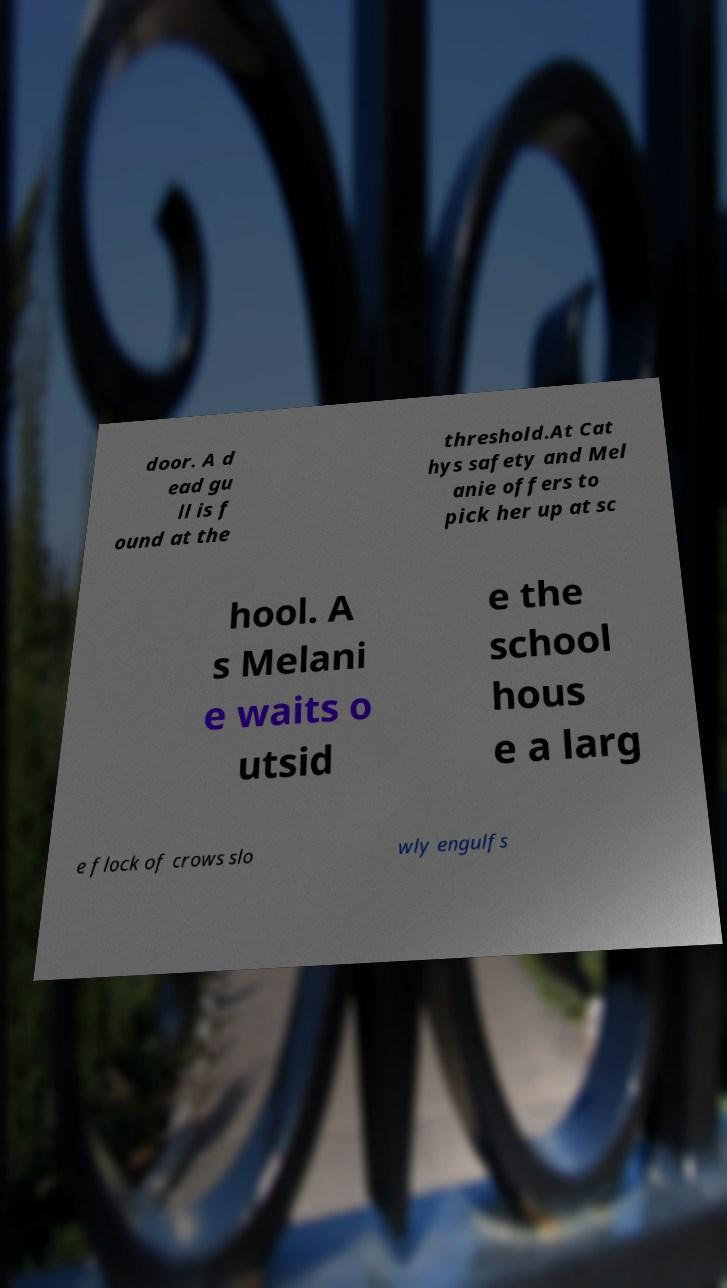Could you assist in decoding the text presented in this image and type it out clearly? door. A d ead gu ll is f ound at the threshold.At Cat hys safety and Mel anie offers to pick her up at sc hool. A s Melani e waits o utsid e the school hous e a larg e flock of crows slo wly engulfs 